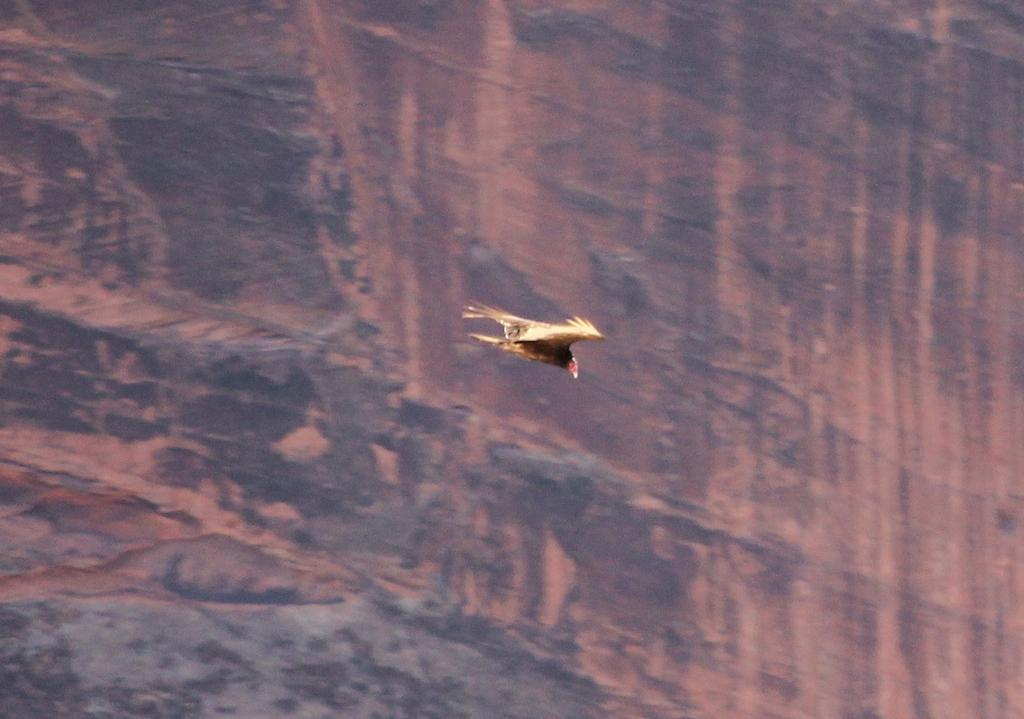What is the main subject in the center of the image? There is a bird in the center of the image. Can you describe the bird's appearance? The bird is brown in color. What can be seen in the background of the image? There is a rock hill in the background of the image. How many eyes does the bird have on its face in the image? The image does not show the bird's eyes or face, so it is not possible to determine the number of eyes on its face. 